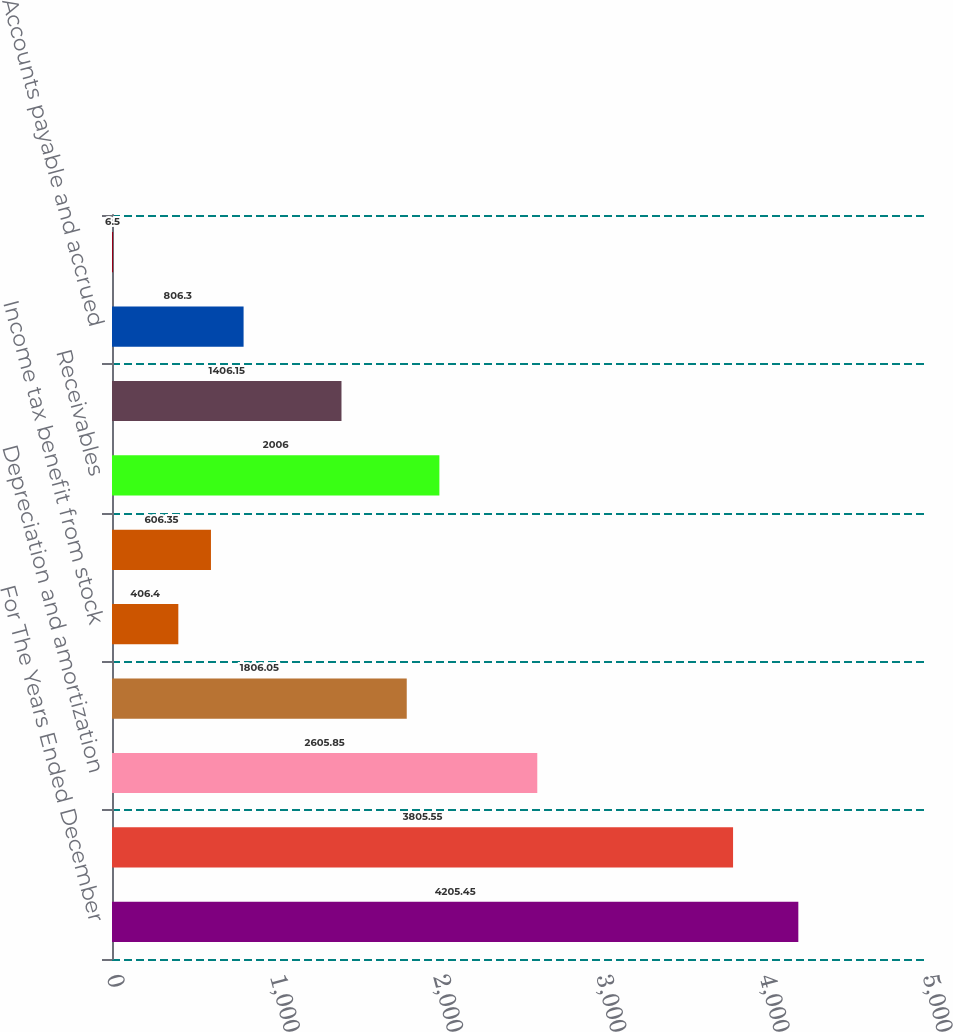Convert chart to OTSL. <chart><loc_0><loc_0><loc_500><loc_500><bar_chart><fcel>For The Years Ended December<fcel>Net earnings<fcel>Depreciation and amortization<fcel>Deferred income tax provision<fcel>Income tax benefit from stock<fcel>Income taxes payable<fcel>Receivables<fcel>Inventories<fcel>Accounts payable and accrued<fcel>Other assets and liabilities<nl><fcel>4205.45<fcel>3805.55<fcel>2605.85<fcel>1806.05<fcel>406.4<fcel>606.35<fcel>2006<fcel>1406.15<fcel>806.3<fcel>6.5<nl></chart> 